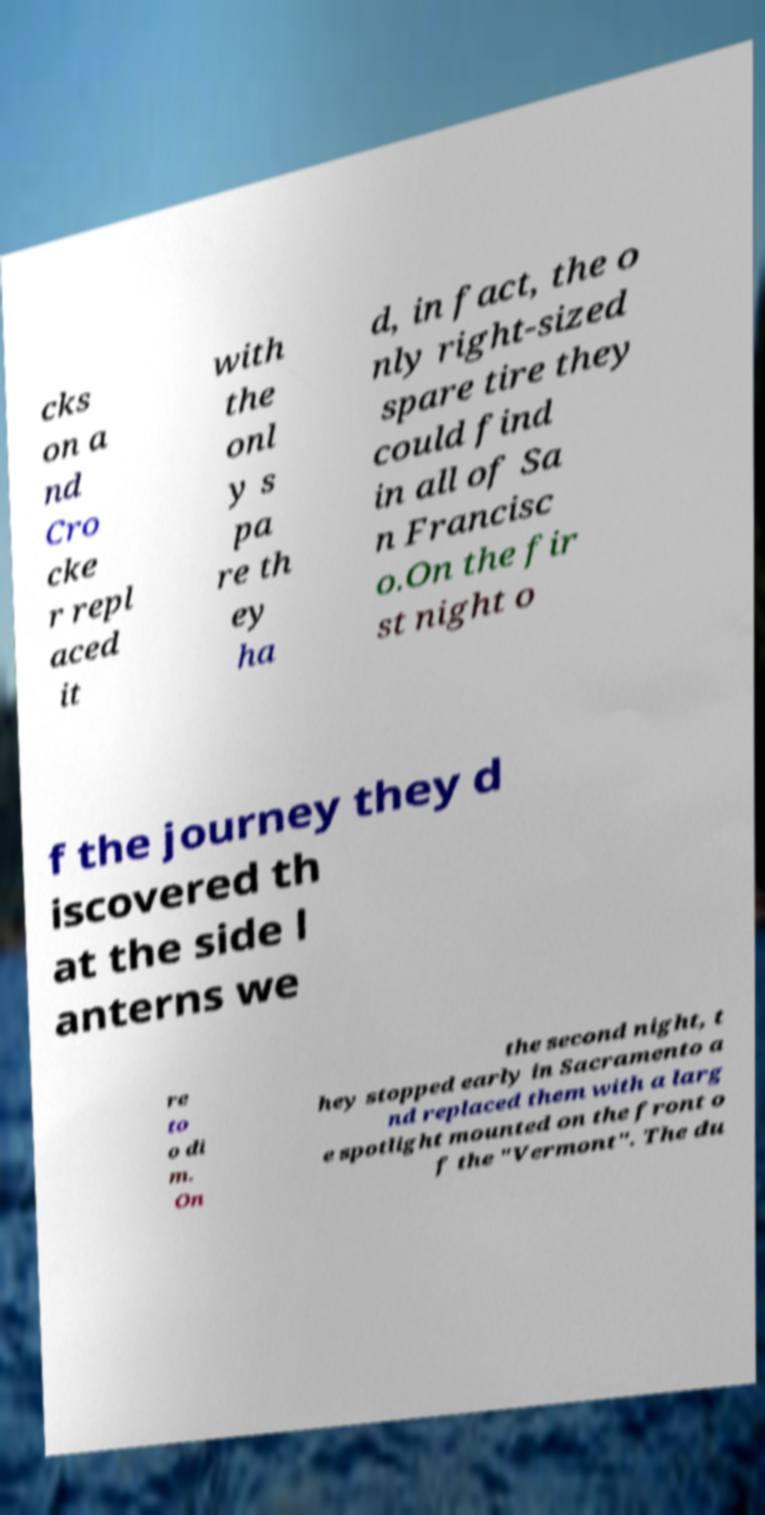Could you extract and type out the text from this image? cks on a nd Cro cke r repl aced it with the onl y s pa re th ey ha d, in fact, the o nly right-sized spare tire they could find in all of Sa n Francisc o.On the fir st night o f the journey they d iscovered th at the side l anterns we re to o di m. On the second night, t hey stopped early in Sacramento a nd replaced them with a larg e spotlight mounted on the front o f the "Vermont". The du 